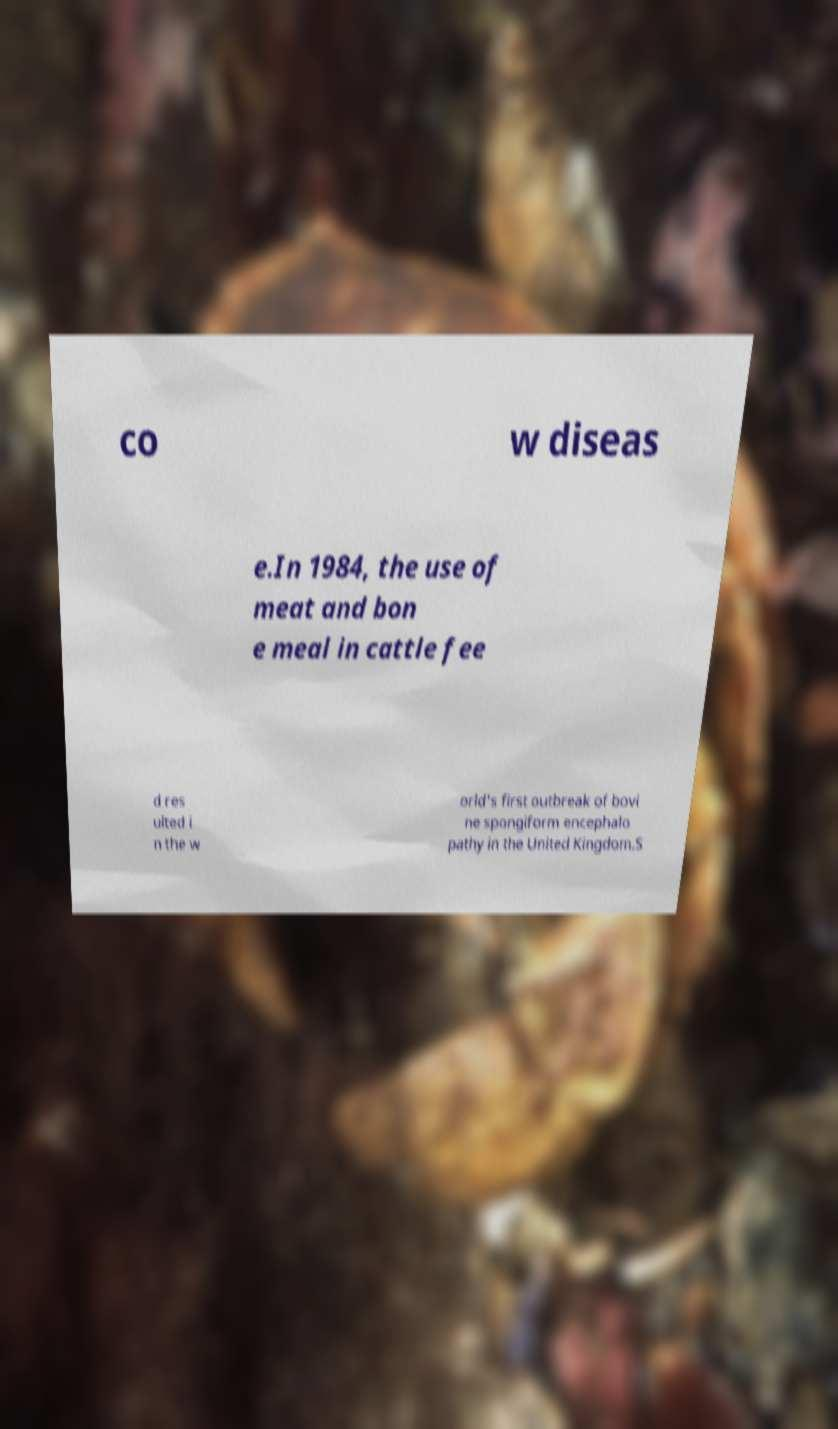What messages or text are displayed in this image? I need them in a readable, typed format. co w diseas e.In 1984, the use of meat and bon e meal in cattle fee d res ulted i n the w orld's first outbreak of bovi ne spongiform encephalo pathy in the United Kingdom.S 